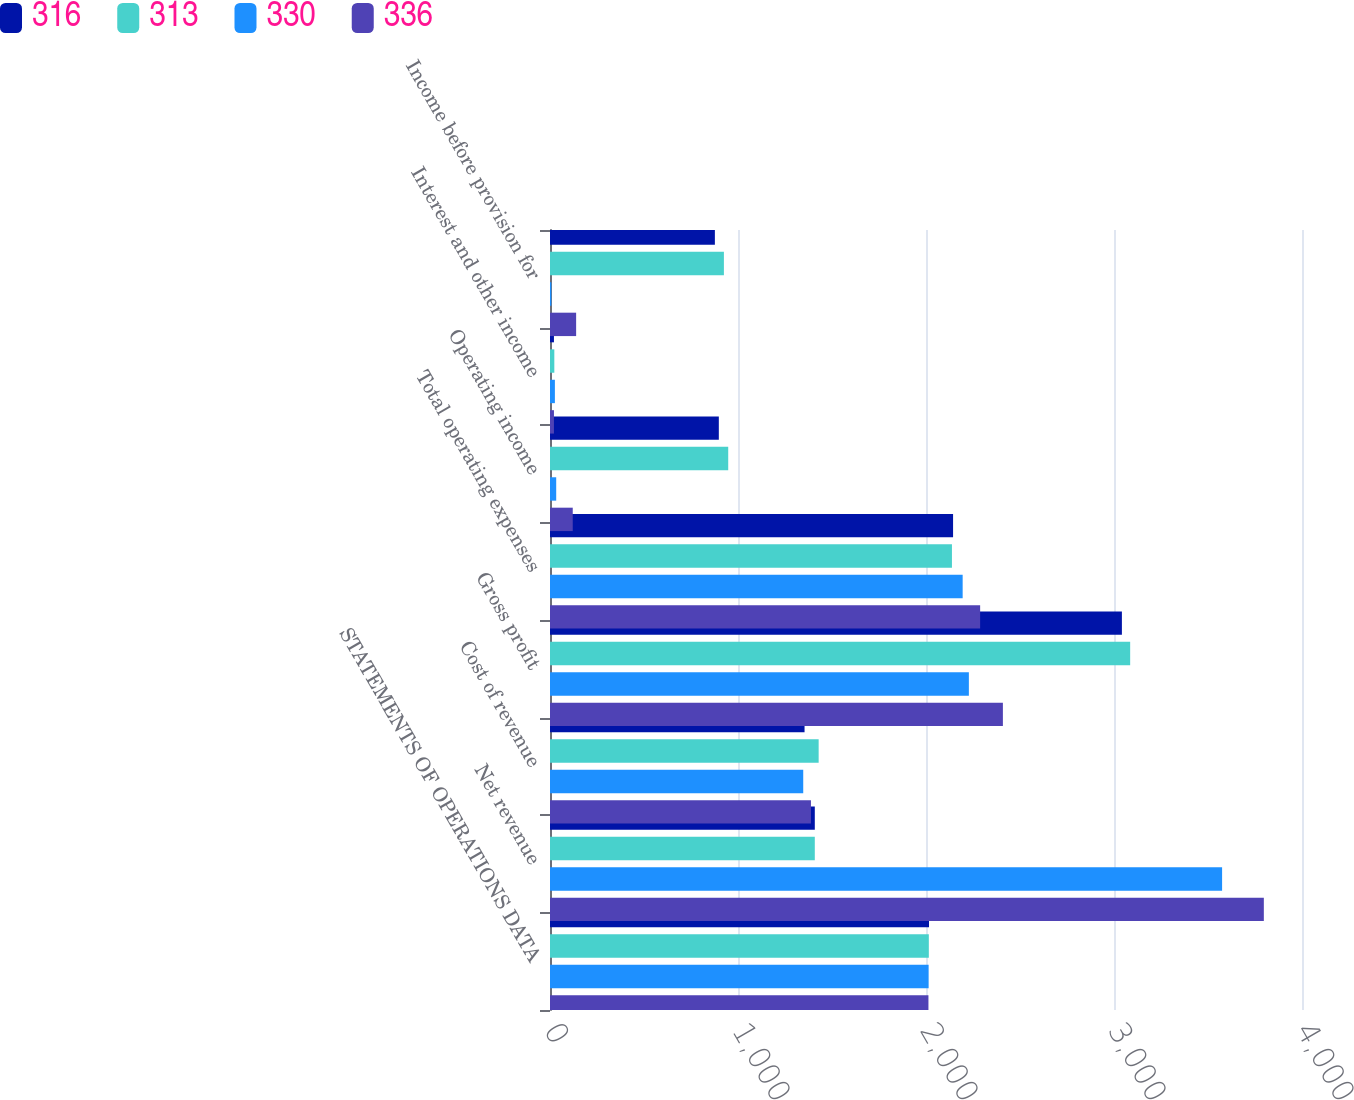Convert chart. <chart><loc_0><loc_0><loc_500><loc_500><stacked_bar_chart><ecel><fcel>STATEMENTS OF OPERATIONS DATA<fcel>Net revenue<fcel>Cost of revenue<fcel>Gross profit<fcel>Total operating expenses<fcel>Operating income<fcel>Interest and other income<fcel>Income before provision for<nl><fcel>316<fcel>2016<fcel>1408.5<fcel>1354<fcel>3042<fcel>2144<fcel>898<fcel>21<fcel>877<nl><fcel>313<fcel>2015<fcel>1408.5<fcel>1429<fcel>3086<fcel>2138<fcel>948<fcel>23<fcel>925<nl><fcel>330<fcel>2014<fcel>3575<fcel>1347<fcel>2228<fcel>2195<fcel>33<fcel>26<fcel>7<nl><fcel>336<fcel>2013<fcel>3797<fcel>1388<fcel>2409<fcel>2288<fcel>121<fcel>21<fcel>139<nl></chart> 